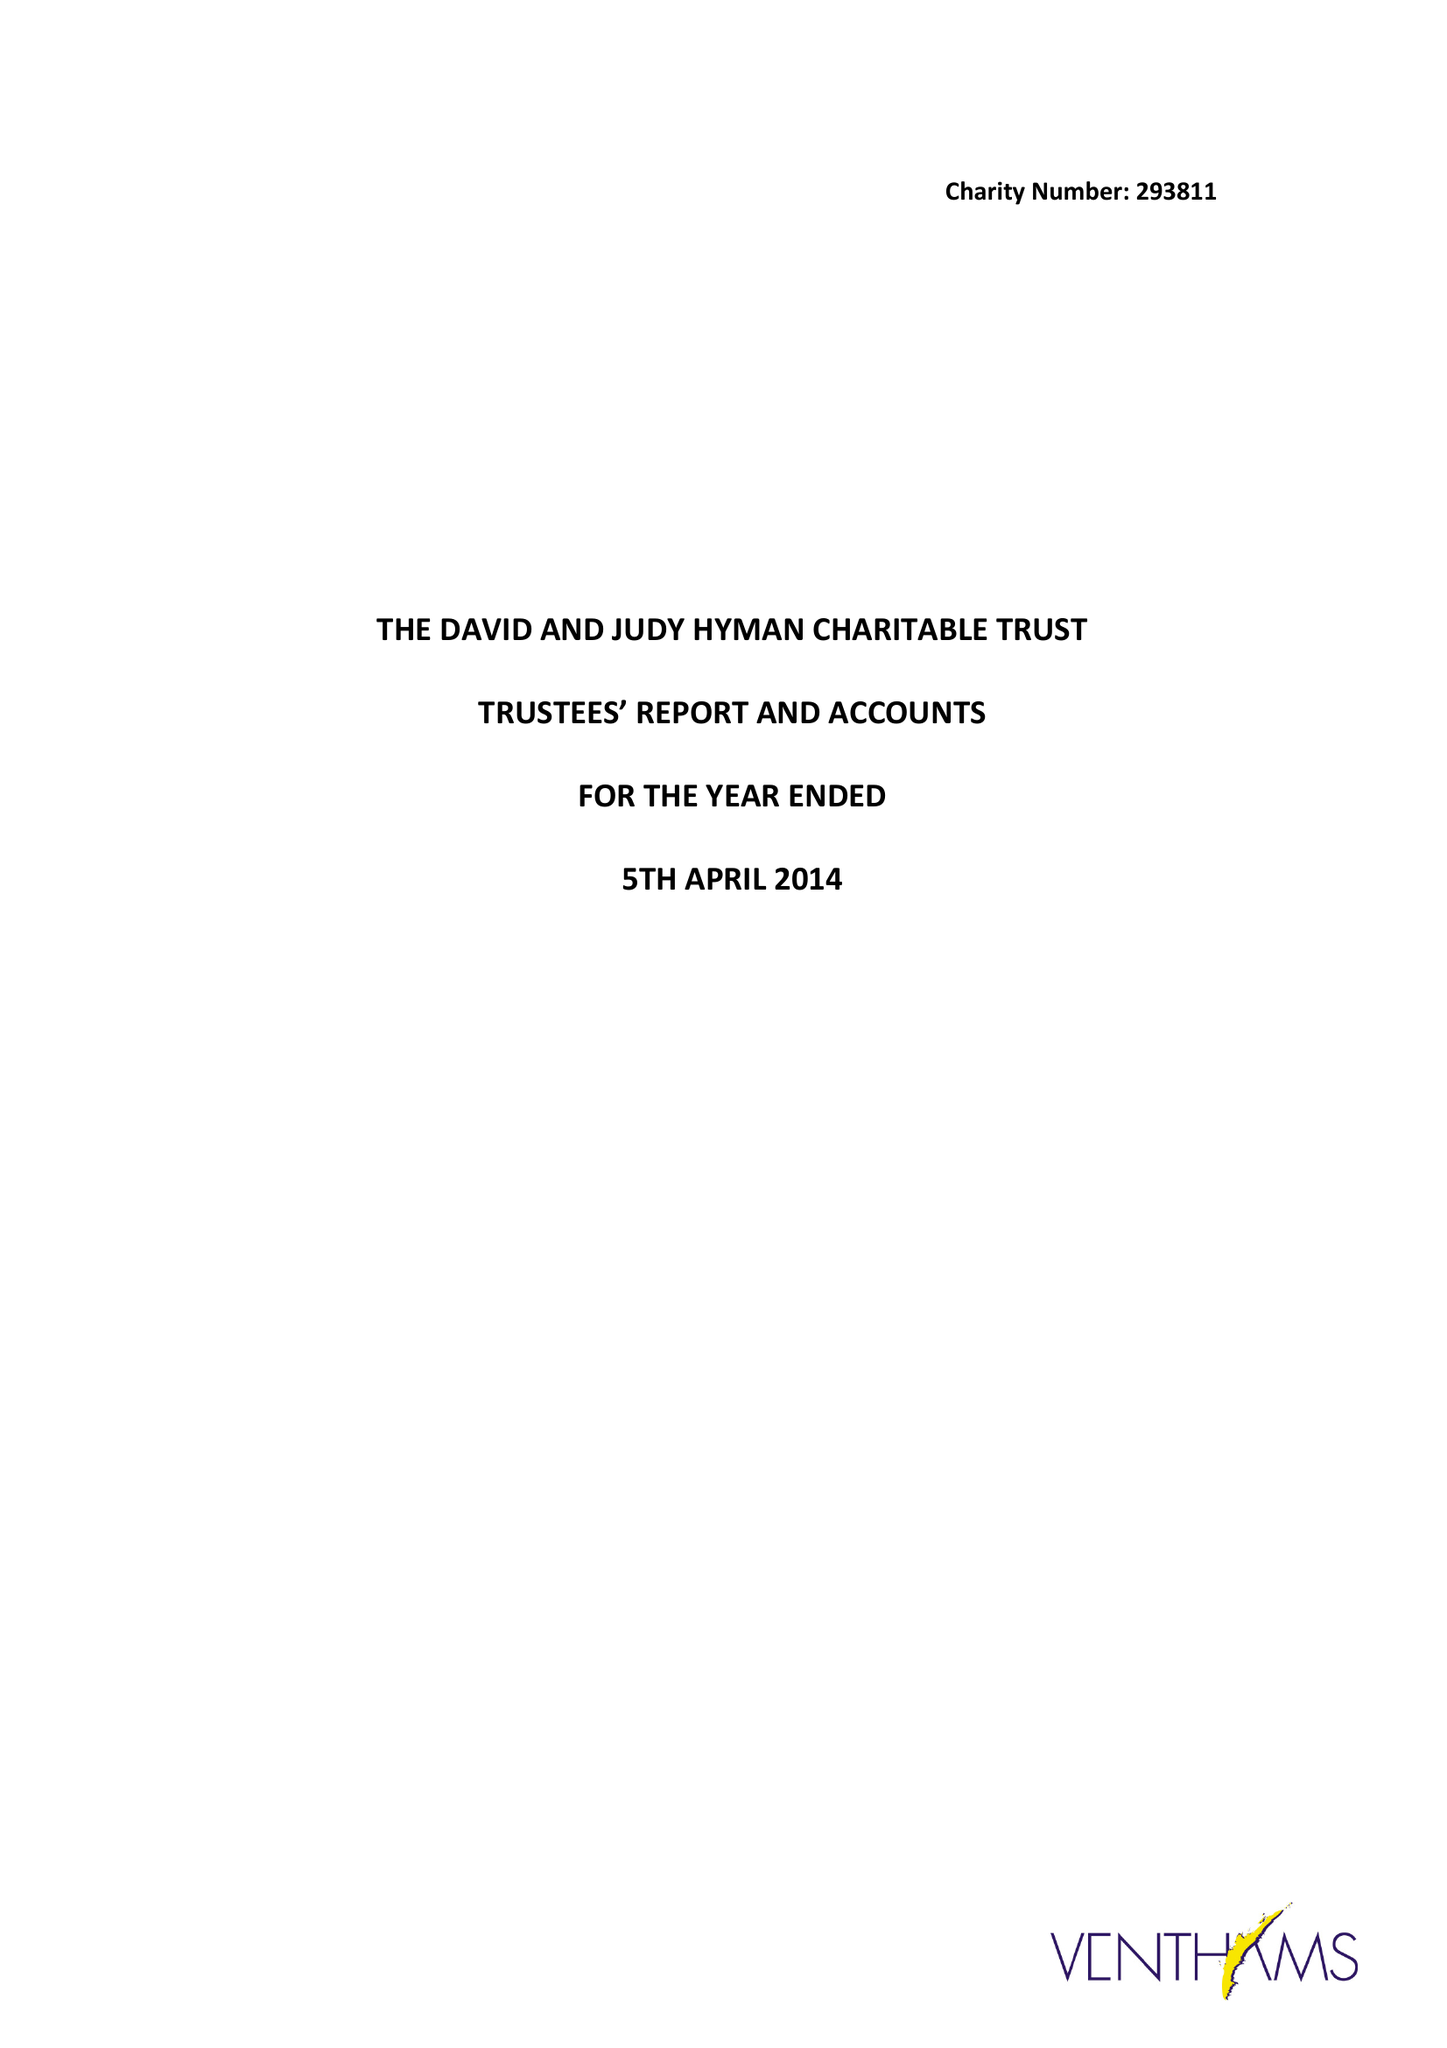What is the value for the report_date?
Answer the question using a single word or phrase. 2014-04-05 